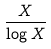<formula> <loc_0><loc_0><loc_500><loc_500>\frac { X } { \log X }</formula> 